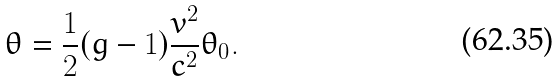<formula> <loc_0><loc_0><loc_500><loc_500>\theta = \frac { 1 } { 2 } ( g - 1 ) \frac { v ^ { 2 } } { c ^ { 2 } } \theta _ { 0 } .</formula> 